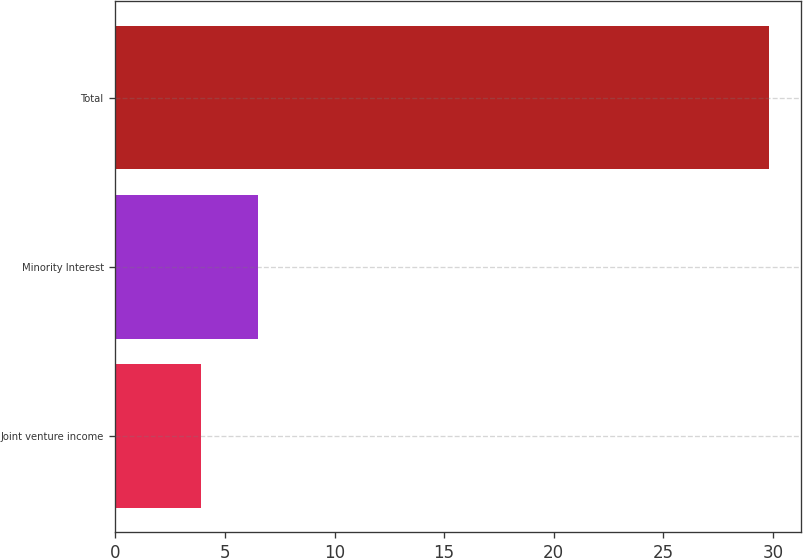Convert chart. <chart><loc_0><loc_0><loc_500><loc_500><bar_chart><fcel>Joint venture income<fcel>Minority Interest<fcel>Total<nl><fcel>3.9<fcel>6.49<fcel>29.8<nl></chart> 